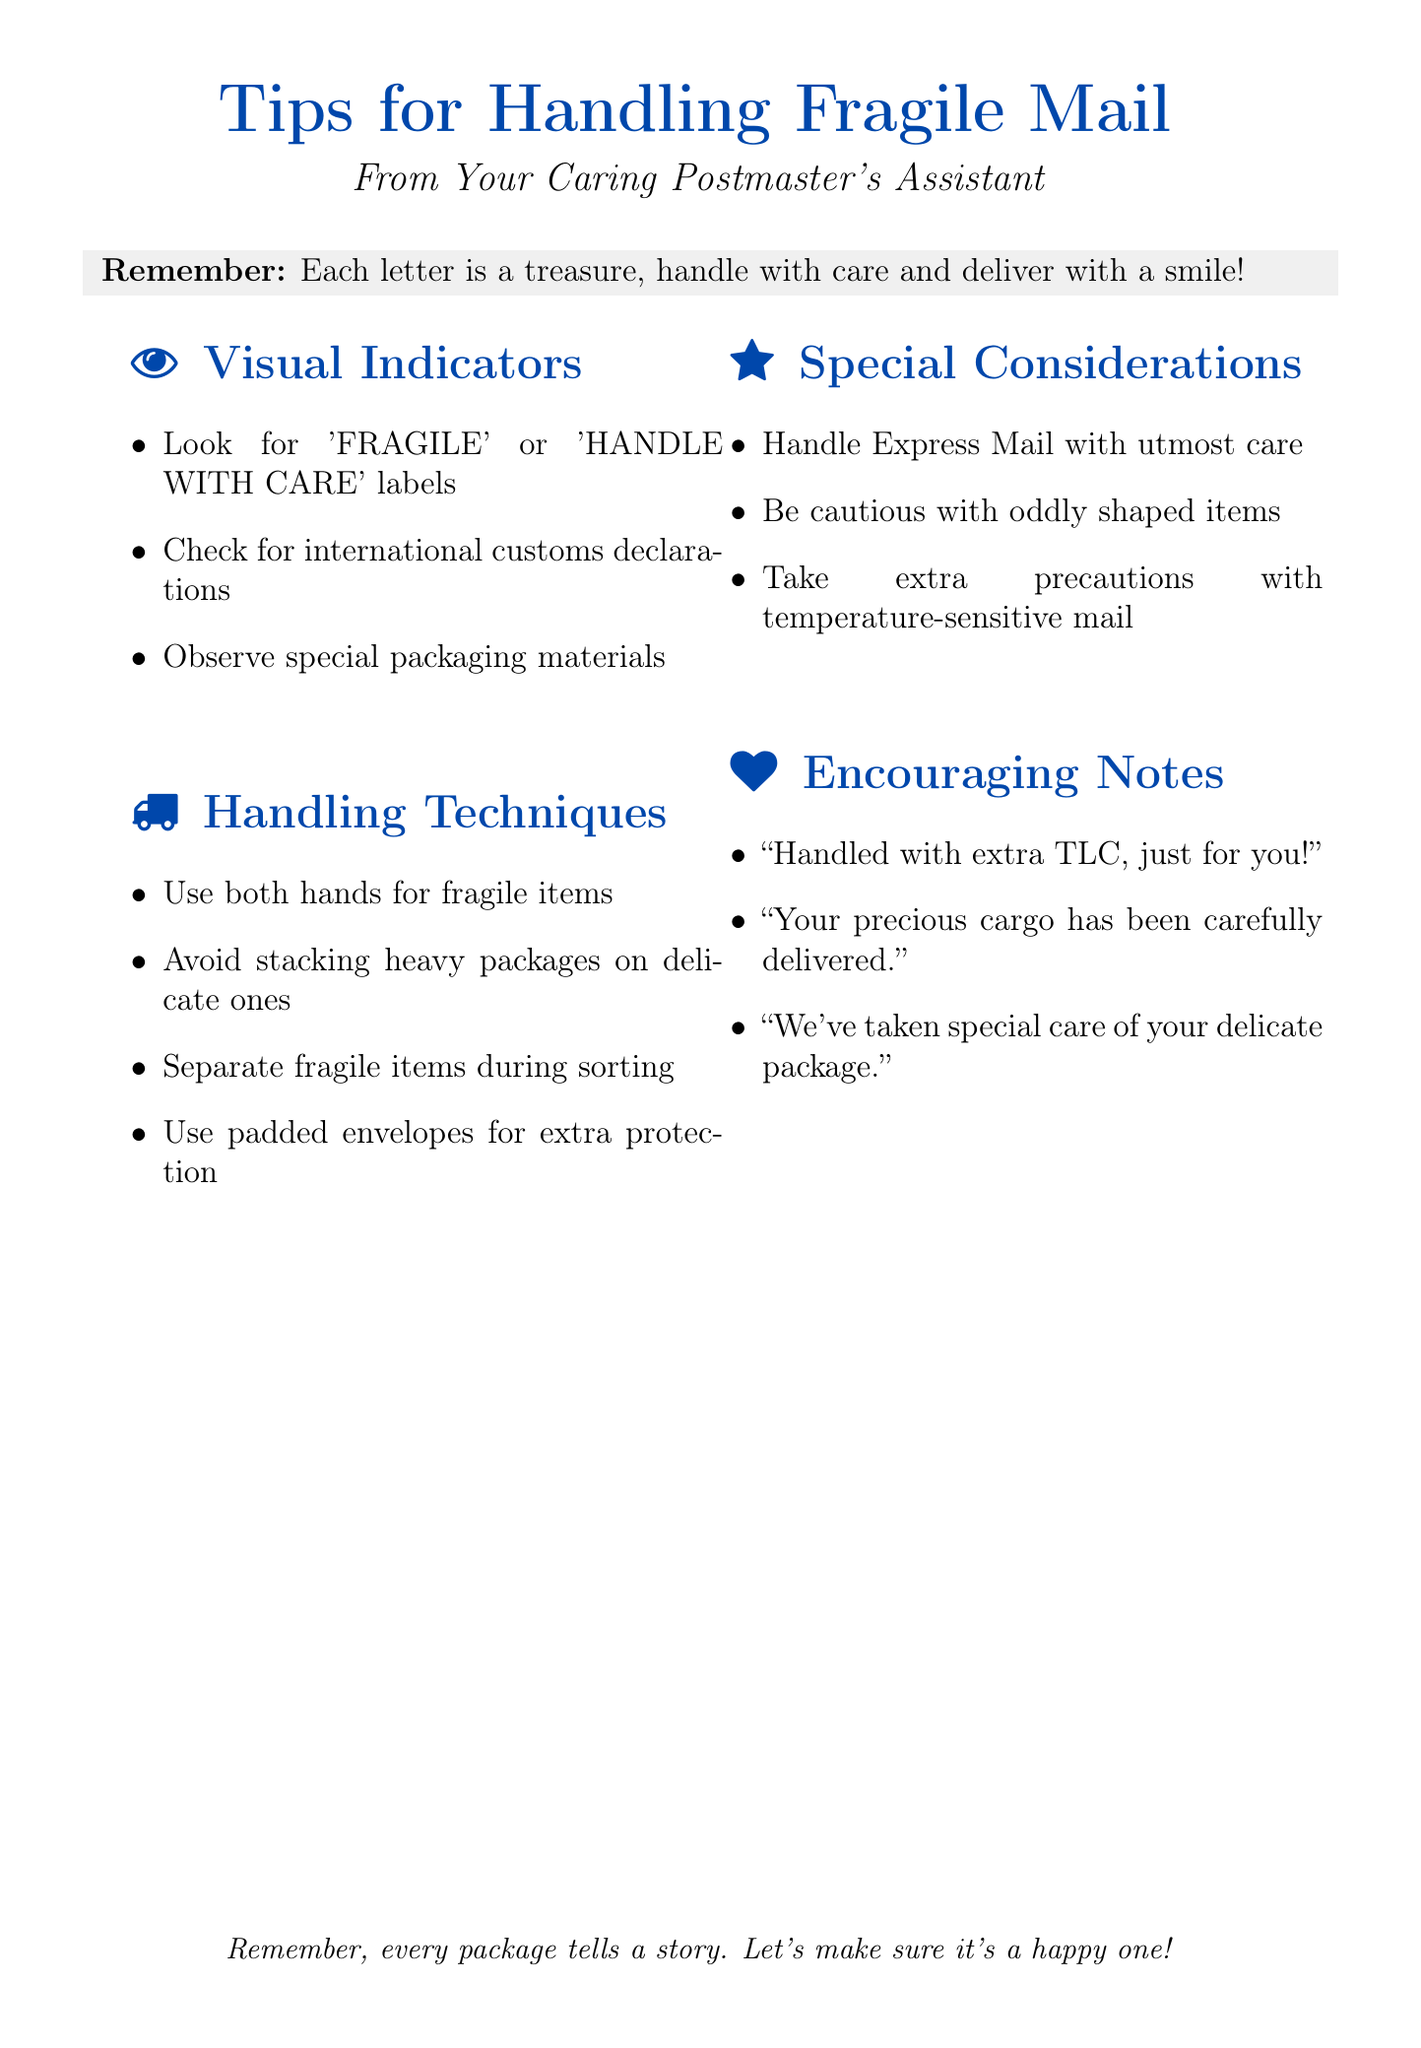What are the visual indicators for fragile mail? The visual indicators list includes labels such as 'FRAGILE' or 'HANDLE WITH CARE', customs declarations, and special packaging materials.
Answer: 'FRAGILE' or 'HANDLE WITH CARE' labels, customs declarations, special packaging materials How should fragile items be carried? The handling techniques recommend using both hands when carrying fragile items.
Answer: Both hands What should you avoid doing with delicate packages? A key handling technique advises avoiding stacking heavy packages on top of delicate ones.
Answer: Stacking heavy packages What types of mail require utmost care? The special considerations section specifies that Express Mail and Priority Mail Express require utmost care.
Answer: Express Mail and Priority Mail Express What encouraging note can be added for fragile items? One of the encouraging notes states, "Handled with extra TLC, just for you!"
Answer: "Handled with extra TLC, just for you!" How many points are listed under Handling Techniques? There are four handling techniques listed under that section of the document.
Answer: Four What materials should be observed for identifying fragile mail? The document suggests observing packaging materials like bubble wrap, foam peanuts, or corrugated cardboard.
Answer: Bubble wrap, foam peanuts, corrugated cardboard What is the purpose of the document? The document provides tips for identifying and handling fragile or sensitive mail with extra care.
Answer: Tips for identifying and handling fragile or sensitive mail What is included in the section on Special Considerations? The section on Special Considerations includes handling guidelines for oddly shaped items and temperature-sensitive mail.
Answer: Oddly shaped items, temperature-sensitive mail 